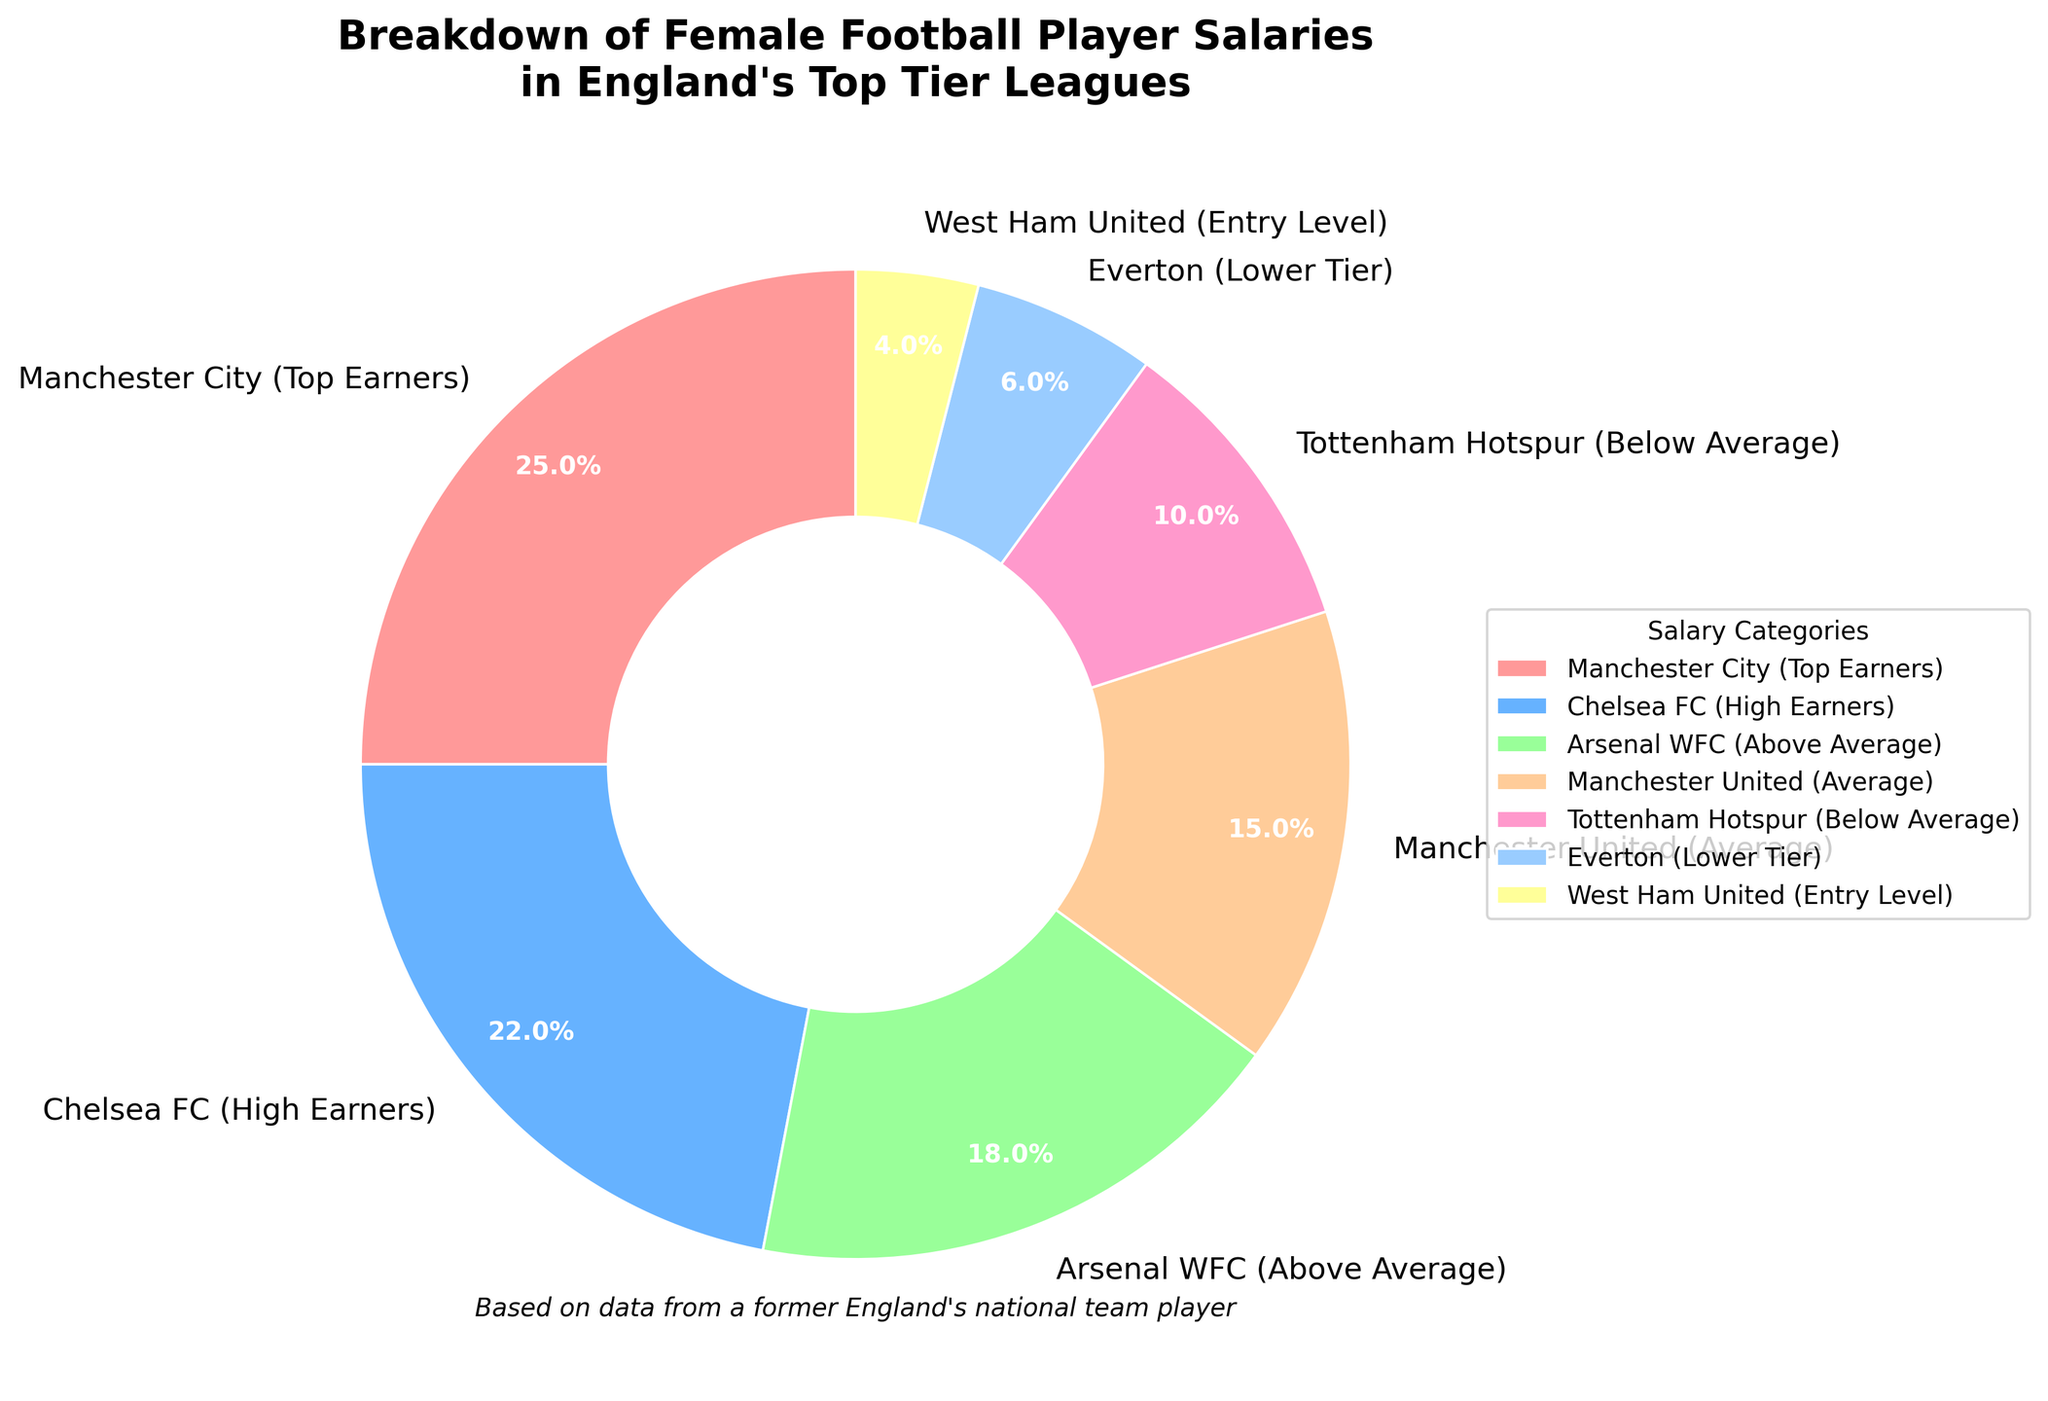What is the percentage of earnings attributed to Chelsea FC (High Earners)? First, locate the segment labeled “Chelsea FC (High Earners)” in the pie chart. Then, check the percentage listed next to it.
Answer: 22% Which club has the highest earnings among female football players in the chart? Identify the largest segment in the pie chart with the highest percentage value. The segment labeled "Manchester City (Top Earners)" has the highest percentage.
Answer: Manchester City (Top Earners) What is the combined percentage of earnings for Tottenham Hotspur (Below Average) and Everton (Lower Tier)? Find the percentages for “Tottenham Hotspur (Below Average)" and "Everton (Lower Tier)" from the chart. Add them together: 10% + 6% = 16%.
Answer: 16% How much more do Manchester City (Top Earners) earn compared to Arsenal WFC (Above Average)? First, find the percentage values for “Manchester City (Top Earners)" and "Arsenal WFC (Above Average)". Subtract Arsenal's percentage (18%) from Manchester City's percentage (25%): 25% - 18% = 7%.
Answer: 7% Which earning category has the smallest percentage, and what is that percentage? Identify the smallest segment in the pie chart. The segment labeled "West Ham United (Entry Level)" has the smallest percentage listed as 4%.
Answer: West Ham United (Entry Level), 4% What is the average earnings percentage among Manchester United (Average), Tottenham Hotspur (Below Average), and Everton (Lower Tier)? Find the percentage values for “Manchester United (Average)”, “Tottenham Hotspur (Below Average)”, and “Everton (Lower Tier)”. Add them up and divide by the number of categories: (15% + 10% + 6%)/3 = 10.33%.
Answer: 10.33% How do Arsenal WFC (Above Average) earnings compare to Chelsea FC (High Earners)? Compare the percentages for “Arsenal WFC (Above Average)" and "Chelsea FC (High Earners)". Arsenal has 18% and Chelsea has 22%. Arsenal has a lower percentage than Chelsea.
Answer: Chelsea FC (High Earners) earns more Which category shares the same color as the West Ham United (Entry Level) segment in the pie chart? Find the color used for “West Ham United (Entry Level)” segment. Identify the other segments with the same color. Upon inspection, the color #FFFF99 (light yellow) corresponds solely to "West Ham United (Entry Level)."
Answer: West Ham United (Entry Level) What is the total percentage accounted for by Manchester City (Top Earners), Chelsea FC (High Earners), and Arsenal WFC (Above Average)? Sum the percentages for “Manchester City (Top Earners)”, “Chelsea FC (High Earners)”, and “Arsenal WFC (Above Average)": 25% + 22% + 18% = 65%.
Answer: 65% How many clubs earn more than 15%? Identify the segments with percentages higher than 15%. The relevant clubs are “Manchester City (Top Earners)", “Chelsea FC (High Earners)", and "Arsenal WFC (Above Average)". Count them: 3 clubs.
Answer: 3 